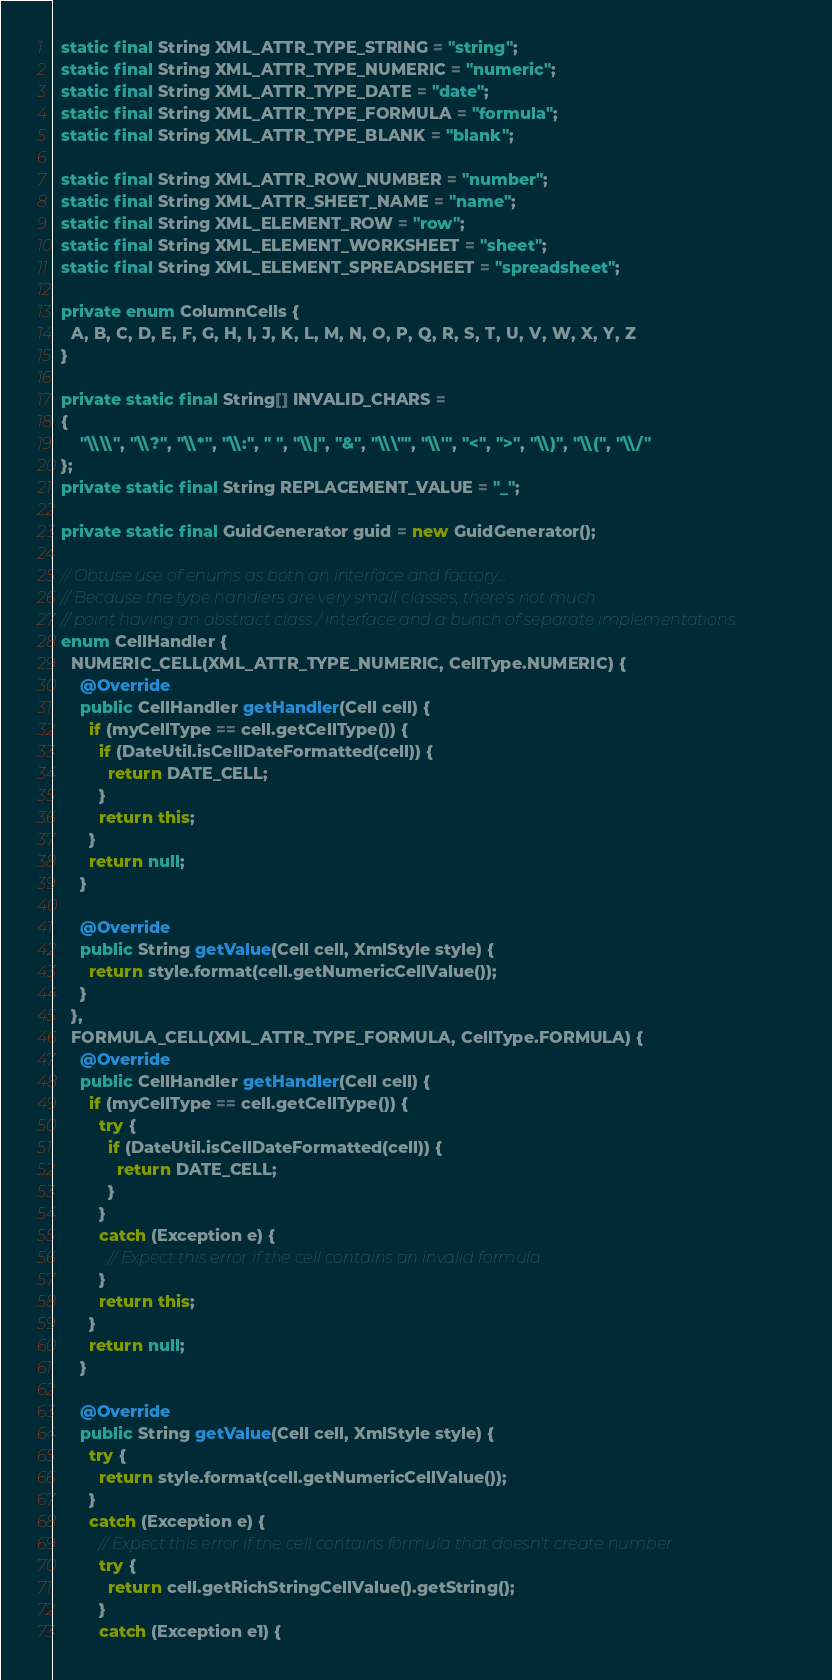<code> <loc_0><loc_0><loc_500><loc_500><_Java_>  static final String XML_ATTR_TYPE_STRING = "string";
  static final String XML_ATTR_TYPE_NUMERIC = "numeric";
  static final String XML_ATTR_TYPE_DATE = "date";
  static final String XML_ATTR_TYPE_FORMULA = "formula";
  static final String XML_ATTR_TYPE_BLANK = "blank";

  static final String XML_ATTR_ROW_NUMBER = "number";
  static final String XML_ATTR_SHEET_NAME = "name";
  static final String XML_ELEMENT_ROW = "row";
  static final String XML_ELEMENT_WORKSHEET = "sheet";
  static final String XML_ELEMENT_SPREADSHEET = "spreadsheet";

  private enum ColumnCells {
    A, B, C, D, E, F, G, H, I, J, K, L, M, N, O, P, Q, R, S, T, U, V, W, X, Y, Z
  }

  private static final String[] INVALID_CHARS =
  {
      "\\\\", "\\?", "\\*", "\\:", " ", "\\|", "&", "\\\"", "\\'", "<", ">", "\\)", "\\(", "\\/"
  };
  private static final String REPLACEMENT_VALUE = "_";

  private static final GuidGenerator guid = new GuidGenerator();

  // Obtuse use of enums as both an interface and factory...
  // Because the type handlers are very small classes, there's not much
  // point having an abstract class / interface and a bunch of separate implementations.
  enum CellHandler {
    NUMERIC_CELL(XML_ATTR_TYPE_NUMERIC, CellType.NUMERIC) {
      @Override
      public CellHandler getHandler(Cell cell) {
        if (myCellType == cell.getCellType()) {
          if (DateUtil.isCellDateFormatted(cell)) {
            return DATE_CELL;
          }
          return this;
        }
        return null;
      }

      @Override
      public String getValue(Cell cell, XmlStyle style) {
        return style.format(cell.getNumericCellValue());
      }
    },
    FORMULA_CELL(XML_ATTR_TYPE_FORMULA, CellType.FORMULA) {
      @Override
      public CellHandler getHandler(Cell cell) {
        if (myCellType == cell.getCellType()) {
          try {
            if (DateUtil.isCellDateFormatted(cell)) {
              return DATE_CELL;
            }
          }
          catch (Exception e) {
            // Expect this error if the cell contains an invalid formula
          }
          return this;
        }
        return null;
      }

      @Override
      public String getValue(Cell cell, XmlStyle style) {
        try {
          return style.format(cell.getNumericCellValue());
        }
        catch (Exception e) {
          // Expect this error if the cell contains formula that doesn't create number
          try {
            return cell.getRichStringCellValue().getString();
          }
          catch (Exception e1) {</code> 